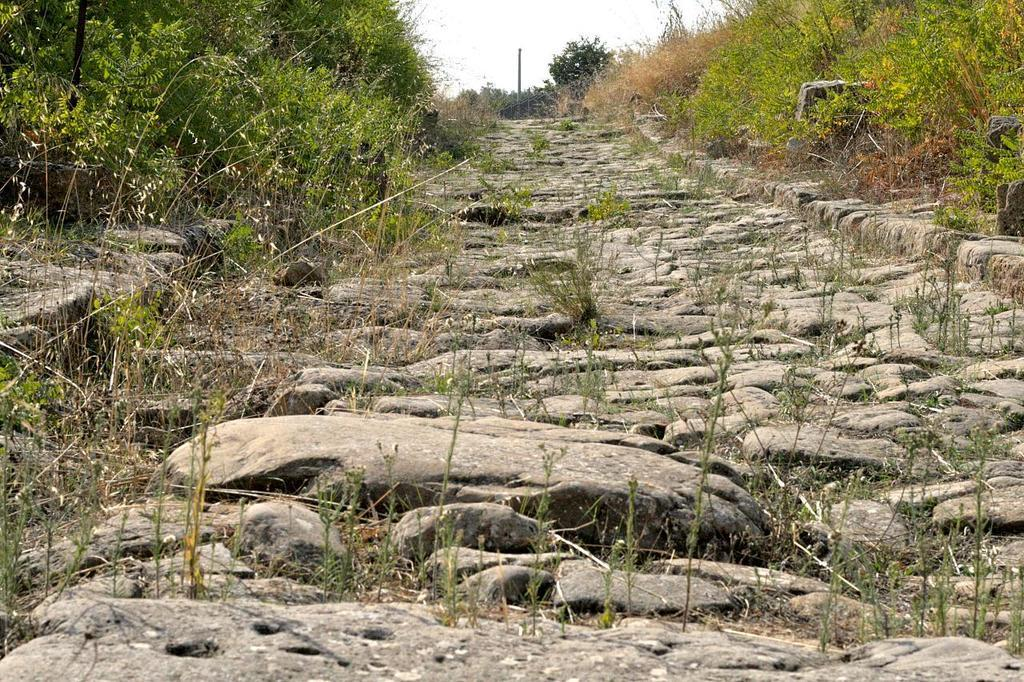What type of path is in the middle of the image? There is a rock path in the middle of the image. What is located on either side of the rock path? Grass and plants are present on either side of the rock path. What can be seen above the rock path? The sky is visible above the rock path. What type of bird is on the list in the image? There is no bird or list present in the image; it features a rock path, grass, plants, and the sky. 